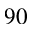Convert formula to latex. <formula><loc_0><loc_0><loc_500><loc_500>^ { 9 0 }</formula> 